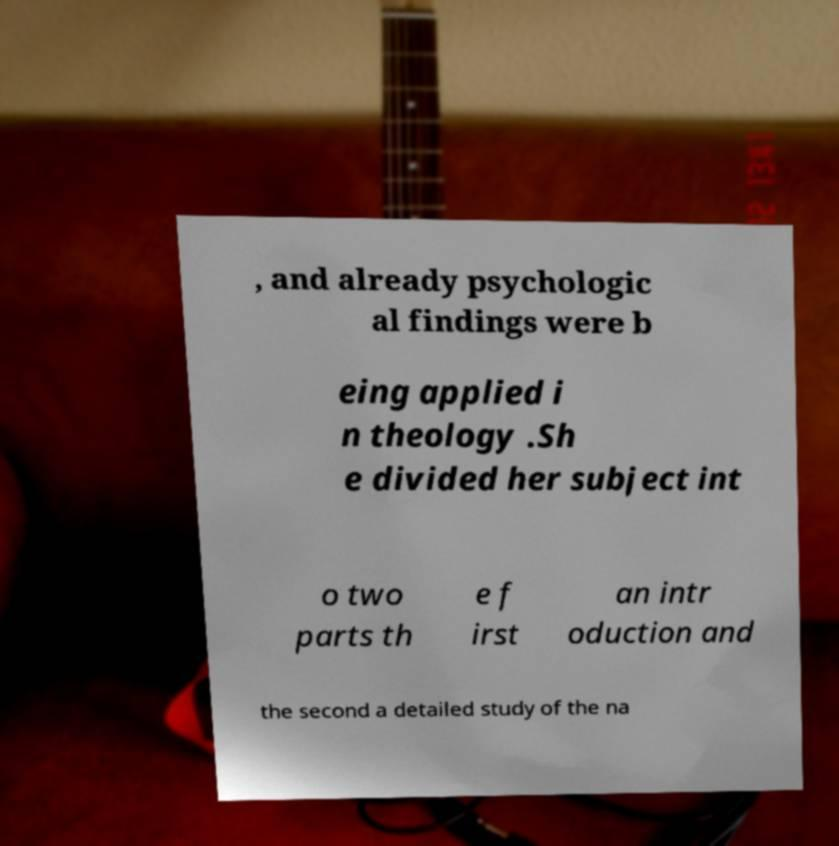Could you extract and type out the text from this image? , and already psychologic al findings were b eing applied i n theology .Sh e divided her subject int o two parts th e f irst an intr oduction and the second a detailed study of the na 